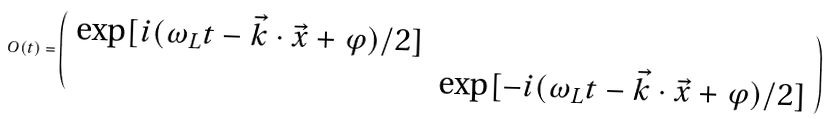Convert formula to latex. <formula><loc_0><loc_0><loc_500><loc_500>O ( t ) = \left ( \begin{array} { c c } \exp [ i ( \omega _ { L } t - \vec { k } \cdot \vec { x } + \varphi ) / 2 ] & \\ & \exp [ - i ( \omega _ { L } t - \vec { k } \cdot \vec { x } + \varphi ) / 2 ] \end{array} \right )</formula> 